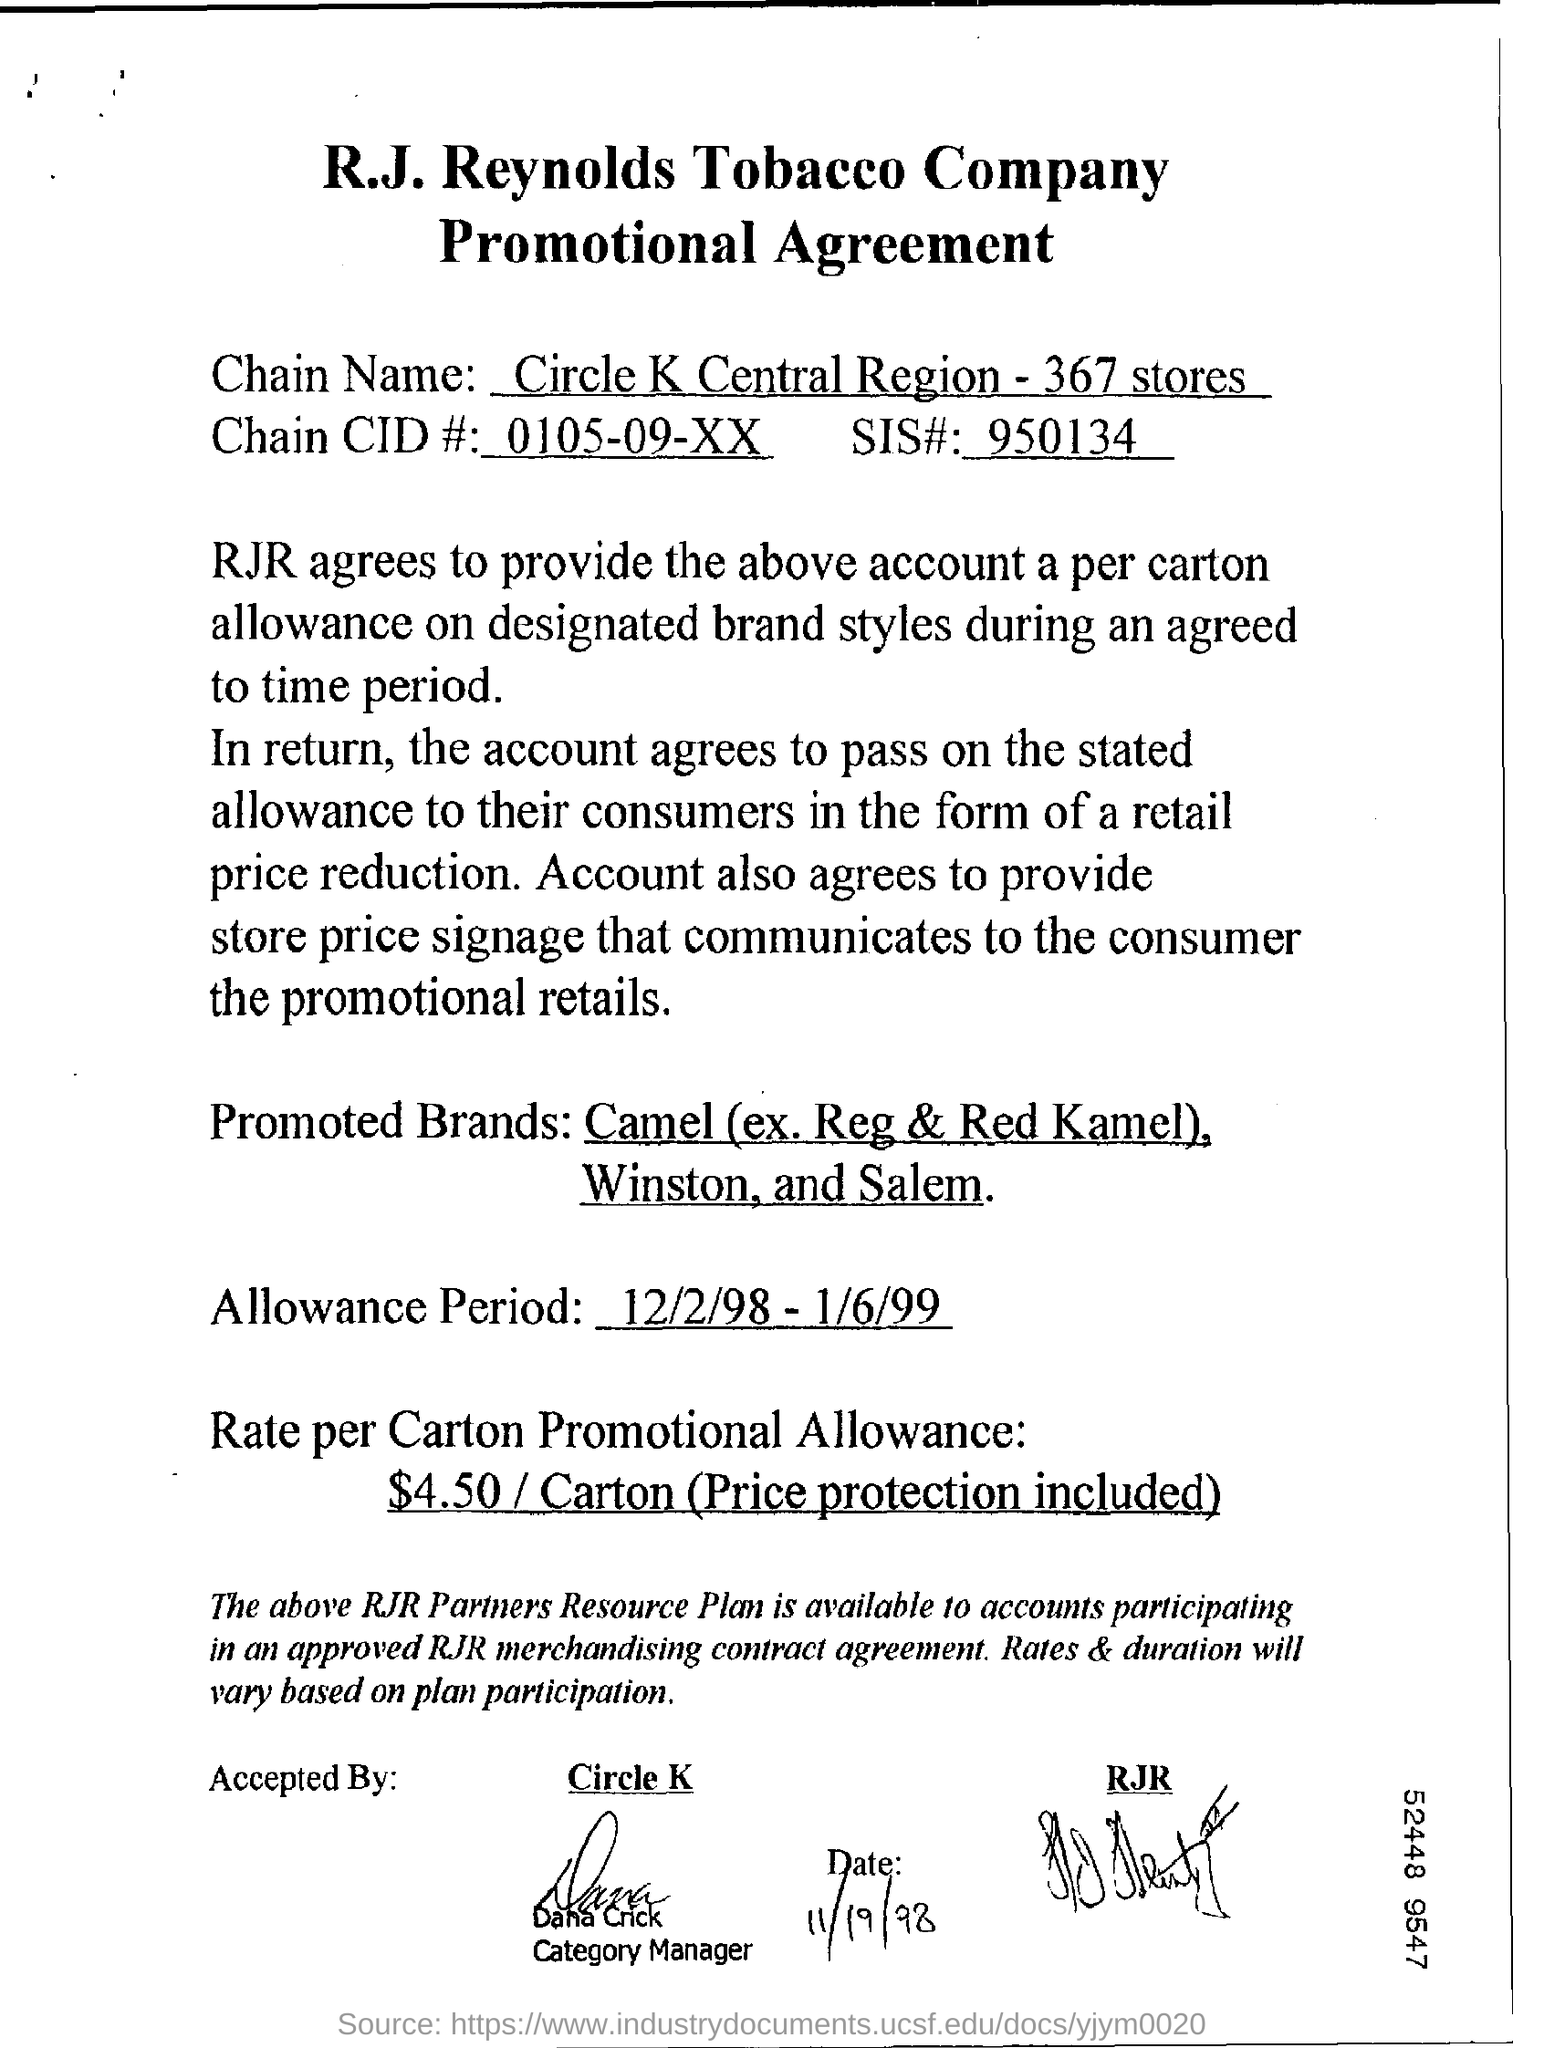what is the rate per carton promotional allowance? The promotional agreement specifies a rate of $4.50 per carton for the promotional allowance, which includes price protection. This rate is part of a marketing arrangement to promote certain brands of cigarettes within a designated period, under specific terms agreed upon by the R.J. Reynolds Tobacco Company and the retailer. 